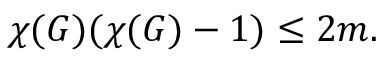<formula> <loc_0><loc_0><loc_500><loc_500>\chi ( G ) ( \chi ( G ) - 1 ) \leq 2 m .</formula> 